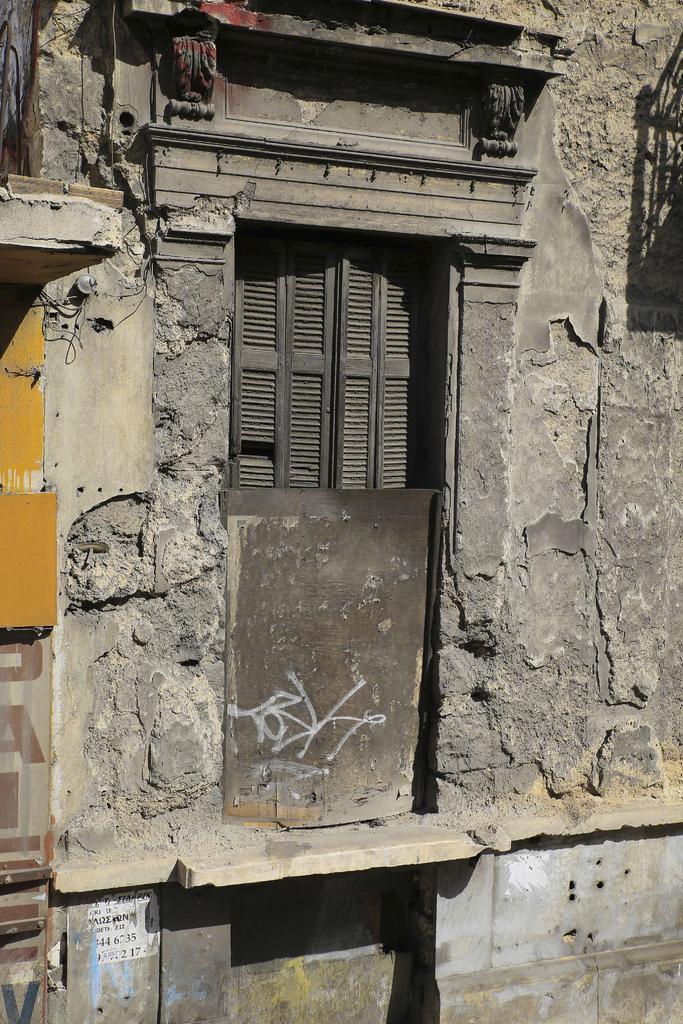Describe this image in one or two sentences. In this image I can see a wall along with the window. On the left side there are few boards attached to the wall. 